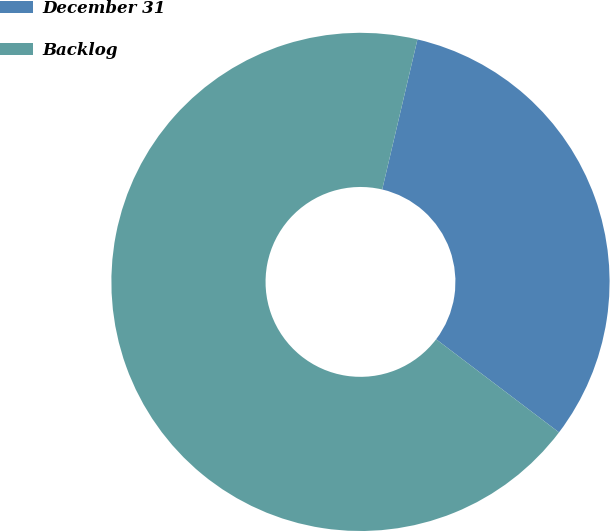Convert chart. <chart><loc_0><loc_0><loc_500><loc_500><pie_chart><fcel>December 31<fcel>Backlog<nl><fcel>31.65%<fcel>68.35%<nl></chart> 